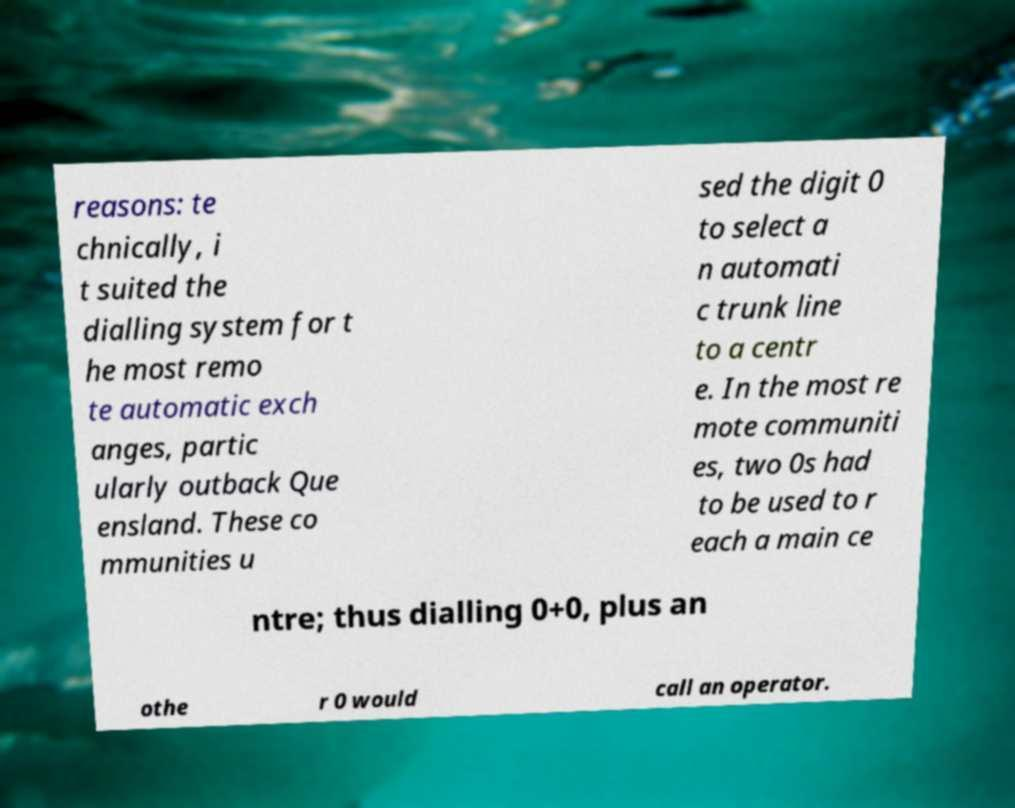There's text embedded in this image that I need extracted. Can you transcribe it verbatim? reasons: te chnically, i t suited the dialling system for t he most remo te automatic exch anges, partic ularly outback Que ensland. These co mmunities u sed the digit 0 to select a n automati c trunk line to a centr e. In the most re mote communiti es, two 0s had to be used to r each a main ce ntre; thus dialling 0+0, plus an othe r 0 would call an operator. 